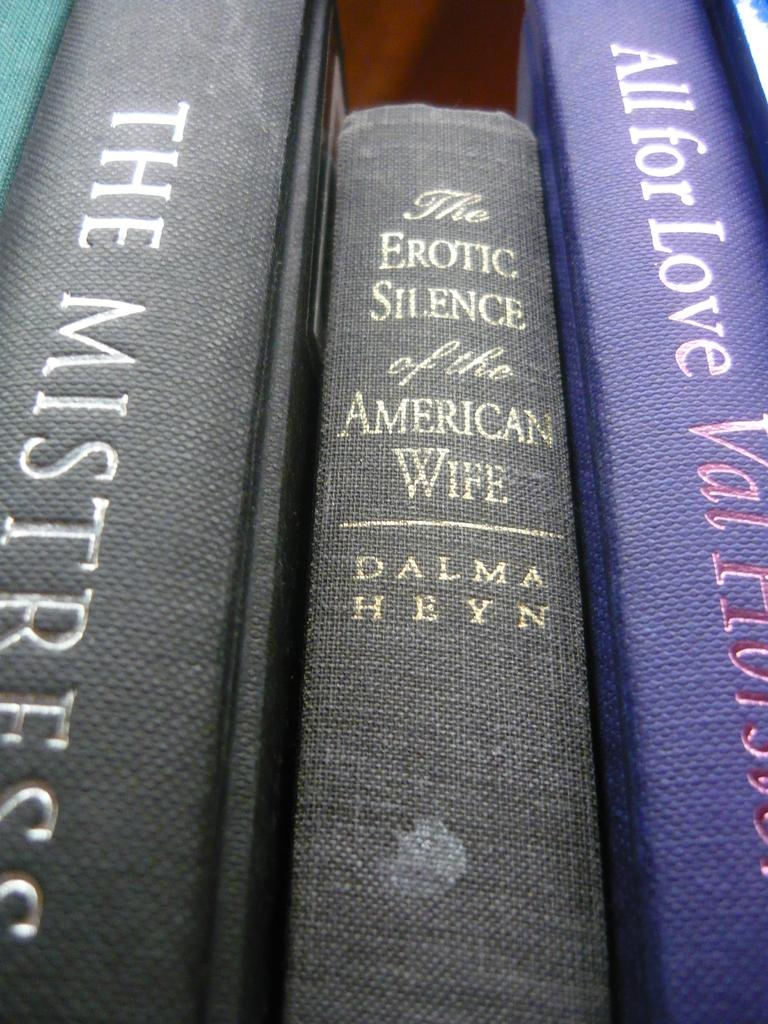<image>
Provide a brief description of the given image. A copy of a book by Dalma Heyn sits on a shelf with some other hardback books. 